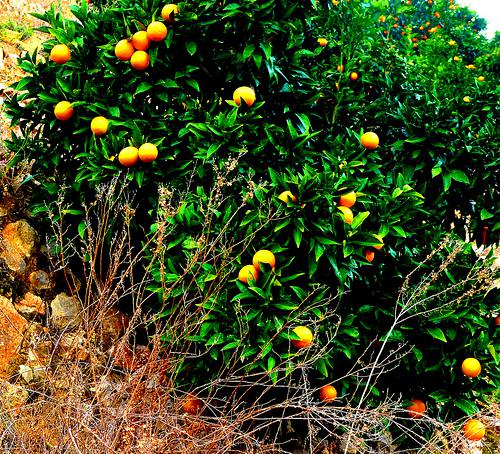Question: when was this photo taken?
Choices:
A. At night.
B. During the day.
C. Afternoon.
D. Dawn.
Answer with the letter. Answer: B Question: where is the bush?
Choices:
A. On the ground.
B. Beside a tree.
C. By the house.
D. In the park.
Answer with the letter. Answer: A Question: what is growing on the bush?
Choices:
A. Oranges.
B. Strawberries.
C. Mulberries.
D. Orange fruit.
Answer with the letter. Answer: D Question: what color are the rocks?
Choices:
A. Gray.
B. Black.
C. White.
D. Orange.
Answer with the letter. Answer: A 